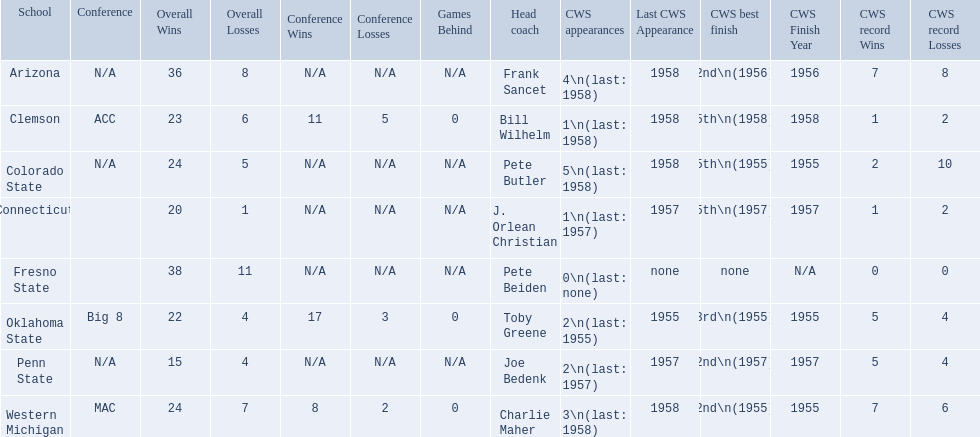How many cws appearances does clemson have? 1\n(last: 1958). How many cws appearances does western michigan have? 3\n(last: 1958). Which of these schools has more cws appearances? Western Michigan. 